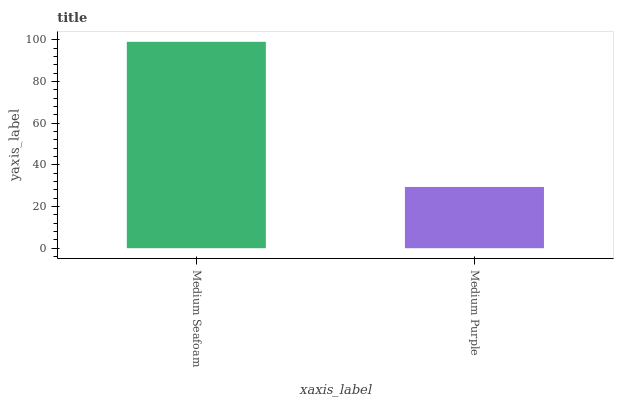Is Medium Purple the minimum?
Answer yes or no. Yes. Is Medium Seafoam the maximum?
Answer yes or no. Yes. Is Medium Purple the maximum?
Answer yes or no. No. Is Medium Seafoam greater than Medium Purple?
Answer yes or no. Yes. Is Medium Purple less than Medium Seafoam?
Answer yes or no. Yes. Is Medium Purple greater than Medium Seafoam?
Answer yes or no. No. Is Medium Seafoam less than Medium Purple?
Answer yes or no. No. Is Medium Seafoam the high median?
Answer yes or no. Yes. Is Medium Purple the low median?
Answer yes or no. Yes. Is Medium Purple the high median?
Answer yes or no. No. Is Medium Seafoam the low median?
Answer yes or no. No. 